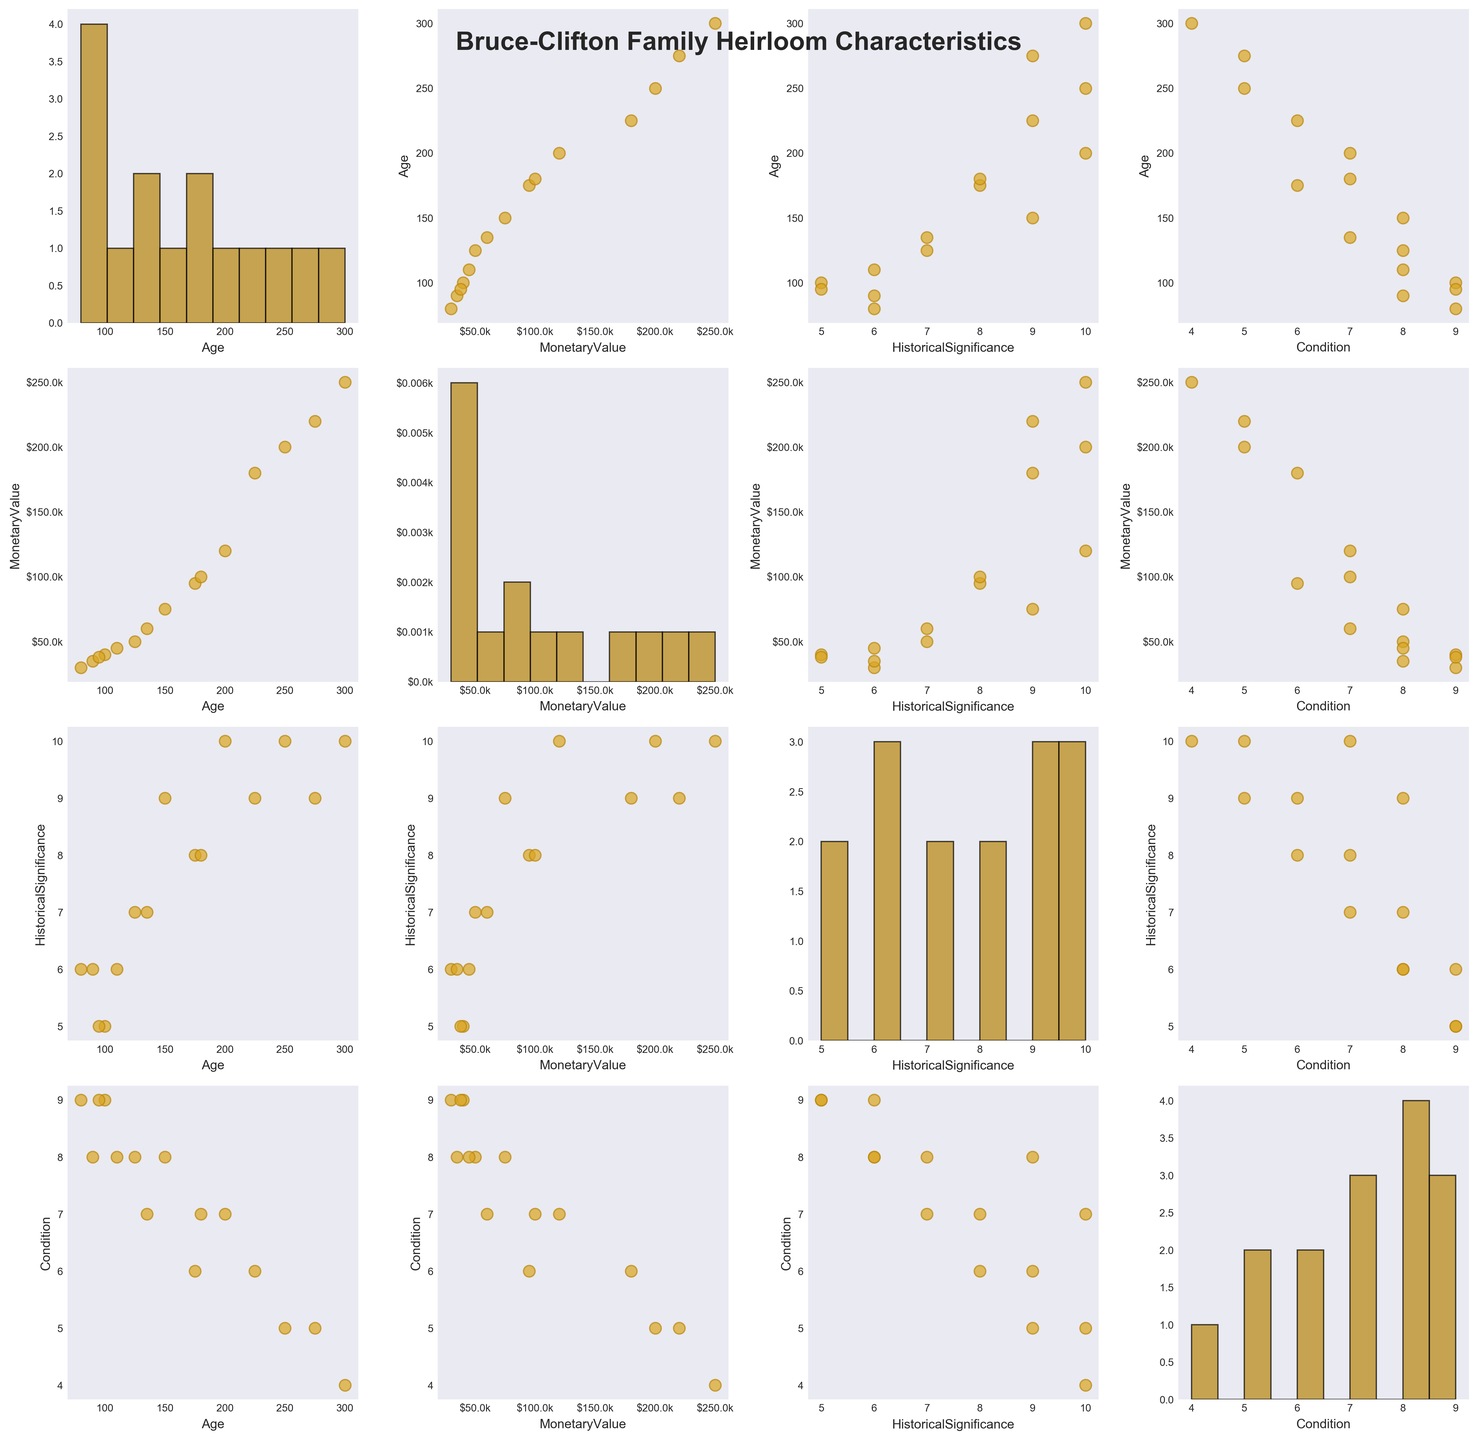How many data points are in each subplot of the scatterplot matrix? Each heirloom represents one data point, and there are 15 heirloom data points in total. Each subplot, which is a combination of two variables, contains all 15 points, but represented in different variable spaces. Count the data points in one of the scatter subplots to verify.
Answer: 15 What color is used for the scatter points and histograms in the scatterplot matrix? The scatter points are colored in goldenrod with an edge color of darkgoldenrod. The histograms use darkgoldenrod as the fill color with a black edge color. Verify by observing the visible colors in the plot.
Answer: Goldenrod for scatter points, darkgoldenrod for histograms, black edges for histograms Is there a trend between Age and Monetary Value? Look at the scatterplot where Age is on the y-axis and Monetary Value is on the x-axis. There seems to be a positive trend where older heirlooms generally have higher monetary value, as indicated by the upward spread of points.
Answer: Positive trend What is the condition of the heirloom with the highest historical significance? Locate the scatterplot where Historical Significance is on the y-axis and Condition on the x-axis. The heirloom with the highest historical significance (a value of 10) has a condition that ranges from 4 to 7 across the data points.
Answer: 4-7 Which variable shows the most variation when looking at its histogram? Compare the histograms along the diagonal of the scatterplot matrix. Age's histogram shows a wide spread indicating it has the most variation, compared to the other variables which show more clustered data.
Answer: Age Are there more heirlooms in good condition (condition >= 7) compared to those in poor condition (condition <= 5)? Count the data points in the Condition histogram. Data points with condition >= 7 appear in the bins on the right, condition <= 5 on the bins to the left. There are more data points in the rightmost bins (good condition) compared to the leftmost bins (poor condition).
Answer: More heirlooms in good condition What is the correlation between Historical Significance and Monetary Value? Observe the scatterplot with Historical Significance on the y-axis and Monetary Value on the x-axis. A visible pattern showing that heirlooms with higher historical significance generally have higher monetary values suggests a positive correlation.
Answer: Positive correlation Which heirloom variable correlates least with Monetary Value? Examine the scatterplots involving Monetary Value. The scatterplot with Condition (y-axis) and Monetary Value (x-axis) shows a more scattered and less distinct pattern, suggesting the weakest correlation compared to Age or Historical Significance.
Answer: Condition Among the heirlooms with monetary values less than $50,000, which ones are older than 100 years? Look at the scatterplot of Monetary Value (x-axis) vs Age (y-axis). Identify data points with x-values less than 50,000 and y-values greater than 100. Heirlooms in this subset are the ones whose monetary value is less than $50,000 and are older than 100 years.
Answer: Specific heirlooms found in the respective region of the scatterplot 